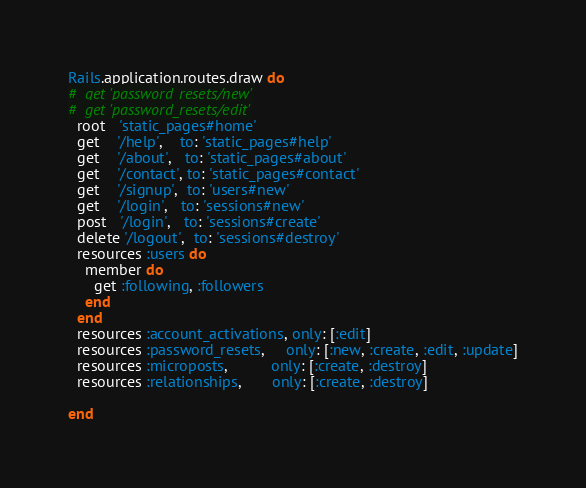<code> <loc_0><loc_0><loc_500><loc_500><_Ruby_>Rails.application.routes.draw do
#  get 'password_resets/new'
#  get 'password_resets/edit'
  root   'static_pages#home'
  get    '/help',    to: 'static_pages#help'
  get    '/about',   to: 'static_pages#about'
  get    '/contact', to: 'static_pages#contact'
  get    '/signup',  to: 'users#new'
  get    '/login',   to: 'sessions#new'
  post   '/login',   to: 'sessions#create'
  delete '/logout',  to: 'sessions#destroy'
  resources :users do
    member do
      get :following, :followers
    end
  end
  resources :account_activations, only: [:edit]
  resources :password_resets,     only: [:new, :create, :edit, :update]
  resources :microposts,          only: [:create, :destroy]
  resources :relationships,       only: [:create, :destroy]

end
</code> 